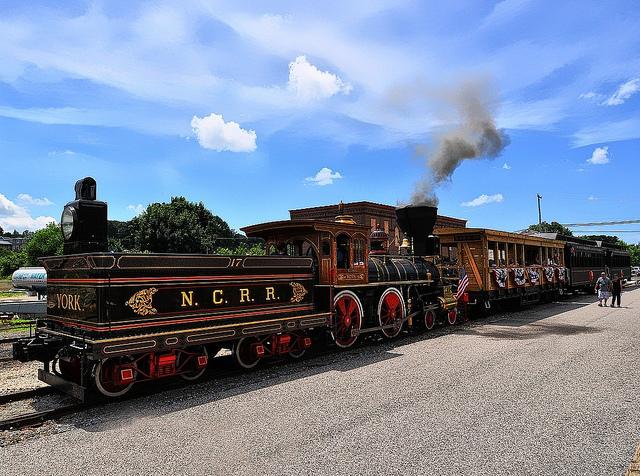What color is the train?
Give a very brief answer. Black. What is written on the nearest car?
Short answer required. Ncrr. Is this train on a track?
Concise answer only. Yes. 